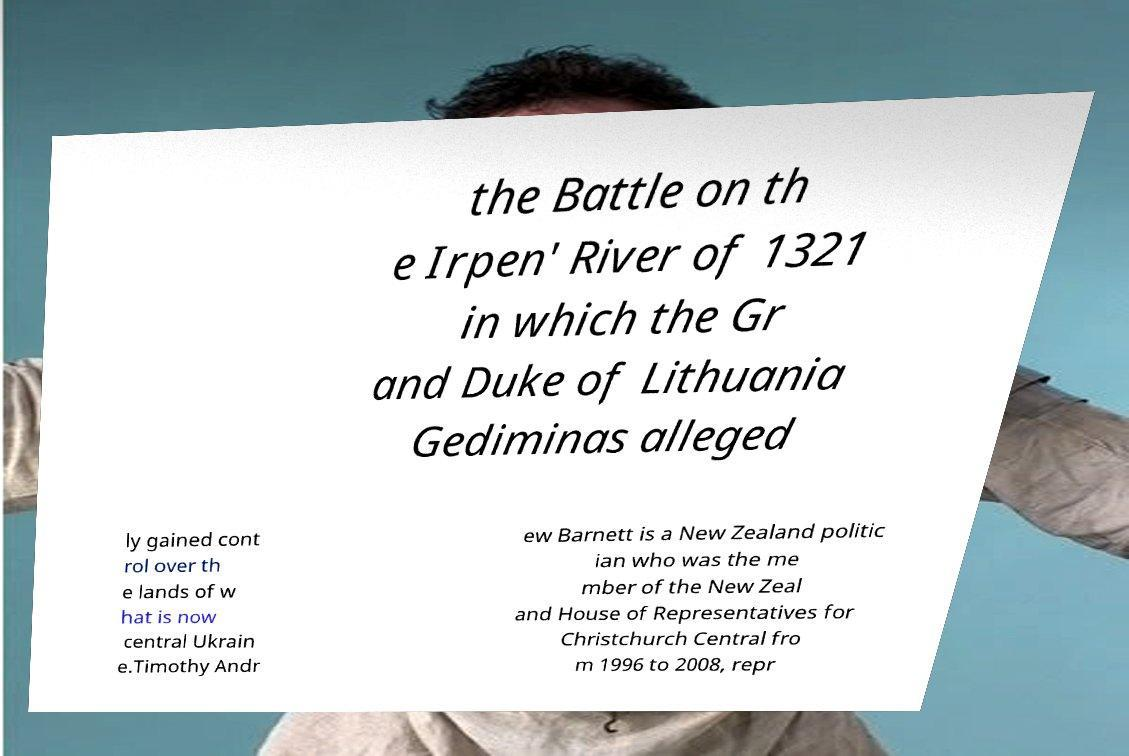What messages or text are displayed in this image? I need them in a readable, typed format. the Battle on th e Irpen' River of 1321 in which the Gr and Duke of Lithuania Gediminas alleged ly gained cont rol over th e lands of w hat is now central Ukrain e.Timothy Andr ew Barnett is a New Zealand politic ian who was the me mber of the New Zeal and House of Representatives for Christchurch Central fro m 1996 to 2008, repr 